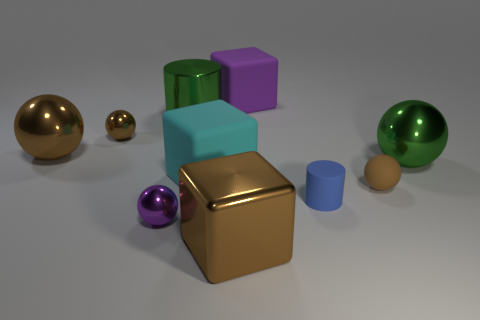Subtract all brown balls. How many were subtracted if there are1brown balls left? 2 Subtract all green cylinders. How many brown balls are left? 3 Subtract all green spheres. How many spheres are left? 4 Subtract all blue balls. Subtract all red cylinders. How many balls are left? 5 Subtract all cubes. How many objects are left? 7 Add 7 small spheres. How many small spheres are left? 10 Add 2 blocks. How many blocks exist? 5 Subtract 0 green cubes. How many objects are left? 10 Subtract all large purple things. Subtract all big rubber things. How many objects are left? 7 